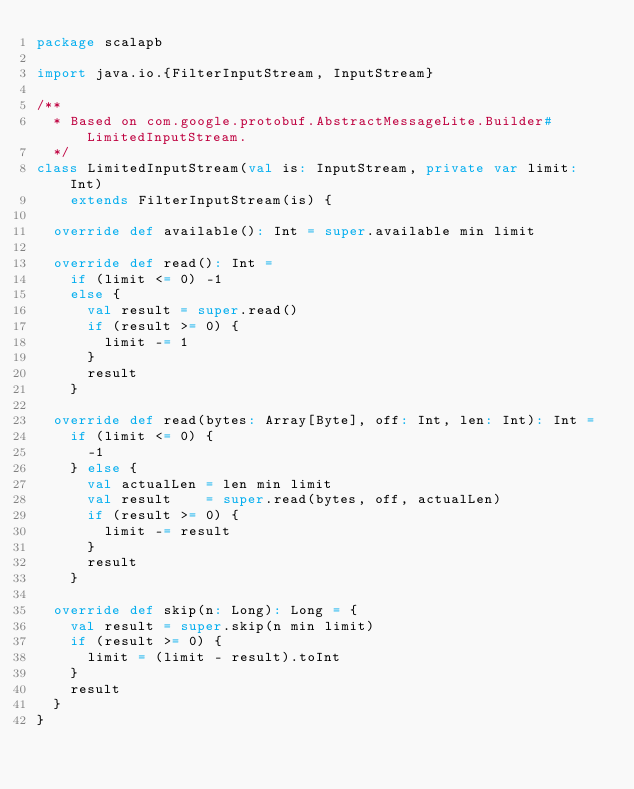Convert code to text. <code><loc_0><loc_0><loc_500><loc_500><_Scala_>package scalapb

import java.io.{FilterInputStream, InputStream}

/**
  * Based on com.google.protobuf.AbstractMessageLite.Builder#LimitedInputStream.
  */
class LimitedInputStream(val is: InputStream, private var limit: Int)
    extends FilterInputStream(is) {

  override def available(): Int = super.available min limit

  override def read(): Int =
    if (limit <= 0) -1
    else {
      val result = super.read()
      if (result >= 0) {
        limit -= 1
      }
      result
    }

  override def read(bytes: Array[Byte], off: Int, len: Int): Int =
    if (limit <= 0) {
      -1
    } else {
      val actualLen = len min limit
      val result    = super.read(bytes, off, actualLen)
      if (result >= 0) {
        limit -= result
      }
      result
    }

  override def skip(n: Long): Long = {
    val result = super.skip(n min limit)
    if (result >= 0) {
      limit = (limit - result).toInt
    }
    result
  }
}
</code> 